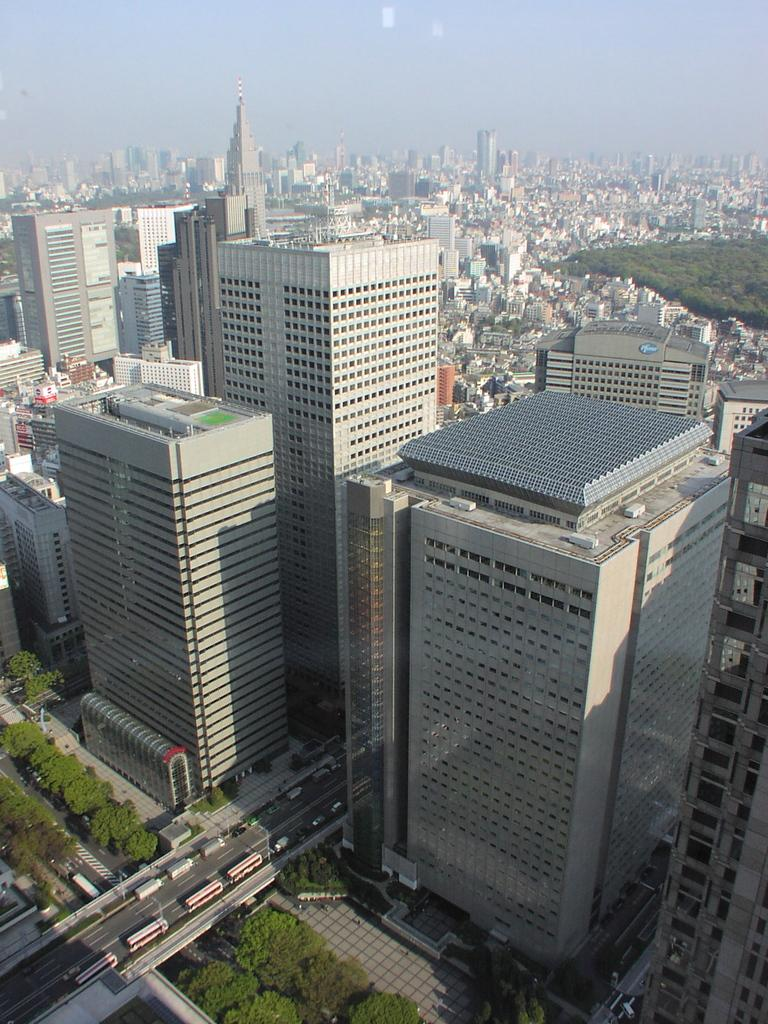What type of vegetation is at the bottom of the image? There are trees at the bottom of the image. What is happening on the road in the image? Vehicles are moving on the road in the image. What structures are located in the middle of the image? There are buildings in the middle of the image. What is visible at the top of the image? The sky is visible at the top of the image. Can you see a pear growing on one of the trees in the image? There is no pear visible in the image; only trees are present at the bottom of the image. What part of the human body is depicted in the image? There is no human body or body part present in the image. 